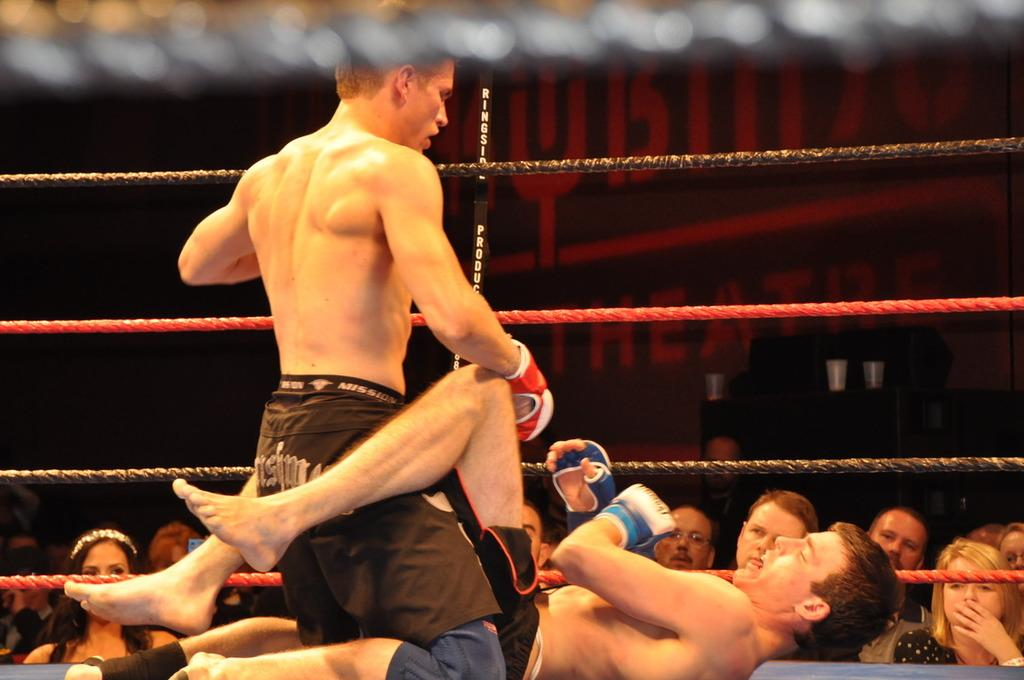What is happening in the boxing ring in the image? There are two persons in the boxing ring, which suggests they are engaged in a boxing match or practice. What can be seen in the background of the image? There is a group of people in the background. What objects have glasses on them? There are glasses on an object, but the specific object is not mentioned in the facts. Can you describe any other items visible in the image? The facts mention that there are other items visible in the image, but they do not specify what these items are. What type of development is the company facing in the image? There is no mention of a company or development in the image; it features a boxing ring with two persons and a group of people in the background. What kind of trouble is the person in the boxing ring experiencing? There is no indication of trouble or any negative emotions in the image; the two persons in the boxing ring are likely engaged in a boxing match or practice. 